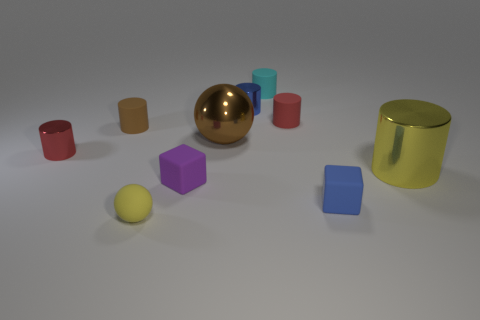Subtract all small red matte cylinders. How many cylinders are left? 5 Subtract all brown balls. How many balls are left? 1 Subtract 1 cubes. How many cubes are left? 1 Subtract all balls. How many objects are left? 8 Subtract all green cylinders. Subtract all yellow spheres. How many cylinders are left? 6 Subtract all brown blocks. How many blue cylinders are left? 1 Subtract all large metal balls. Subtract all yellow rubber objects. How many objects are left? 8 Add 6 small blue shiny things. How many small blue shiny things are left? 7 Add 8 big brown spheres. How many big brown spheres exist? 9 Subtract 0 gray spheres. How many objects are left? 10 